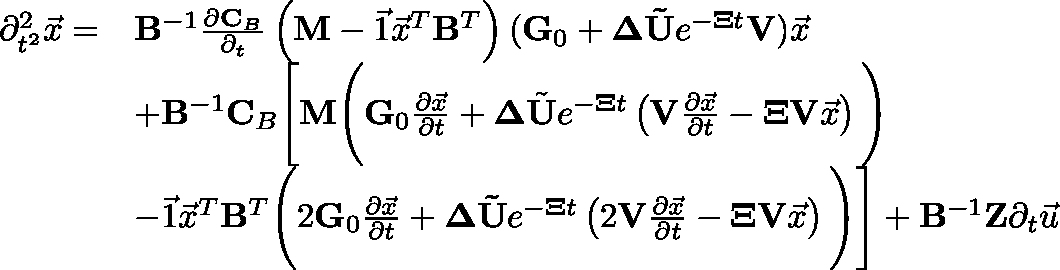<formula> <loc_0><loc_0><loc_500><loc_500>\begin{array} { r l } { \partial _ { t ^ { 2 } } ^ { 2 } \vec { x } = } & { B ^ { - 1 } \frac { \partial C _ { B } } { \partial _ { t } } \left ( M - \vec { 1 } \vec { x } ^ { T } B ^ { T } \right ) ( G _ { 0 } + \Delta \tilde { U } e ^ { - \Xi t } V ) \vec { x } } \\ & { + B ^ { - 1 } C _ { B } \left [ M \left ( G _ { 0 } \frac { \partial \vec { x } } { \partial t } + \Delta \tilde { U } e ^ { - \Xi t } \left ( V \frac { \partial \vec { x } } { \partial t } - \Xi V \vec { x } \right ) \right ) } \\ & { - \vec { 1 } \vec { x } ^ { T } B ^ { T } \left ( 2 G _ { 0 } \frac { \partial \vec { x } } { \partial t } + \Delta \tilde { U } e ^ { - \Xi t } \left ( 2 V \frac { \partial \vec { x } } { \partial t } - \Xi V \vec { x } \right ) \right ) \right ] + B ^ { - 1 } Z \partial _ { t } \vec { u } } \end{array}</formula> 